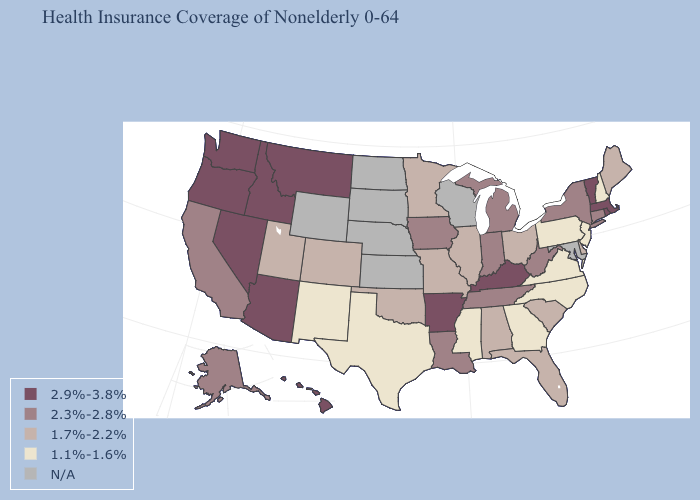Among the states that border Michigan , does Ohio have the highest value?
Write a very short answer. No. What is the highest value in states that border Missouri?
Give a very brief answer. 2.9%-3.8%. Which states hav the highest value in the Northeast?
Concise answer only. Massachusetts, Rhode Island, Vermont. What is the value of Louisiana?
Keep it brief. 2.3%-2.8%. Among the states that border West Virginia , does Kentucky have the lowest value?
Give a very brief answer. No. What is the value of Washington?
Short answer required. 2.9%-3.8%. What is the value of Wyoming?
Give a very brief answer. N/A. What is the value of Florida?
Give a very brief answer. 1.7%-2.2%. Does Rhode Island have the highest value in the USA?
Answer briefly. Yes. Does New Mexico have the lowest value in the West?
Quick response, please. Yes. What is the highest value in the USA?
Answer briefly. 2.9%-3.8%. What is the highest value in the MidWest ?
Keep it brief. 2.3%-2.8%. Does the map have missing data?
Concise answer only. Yes. Among the states that border Connecticut , which have the lowest value?
Short answer required. New York. 